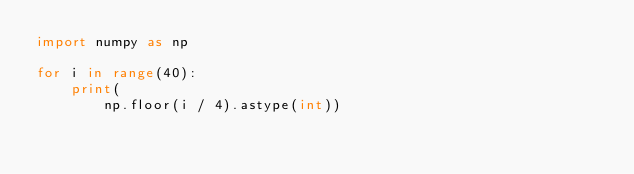<code> <loc_0><loc_0><loc_500><loc_500><_Python_>import numpy as np

for i in range(40):
    print(
        np.floor(i / 4).astype(int))</code> 